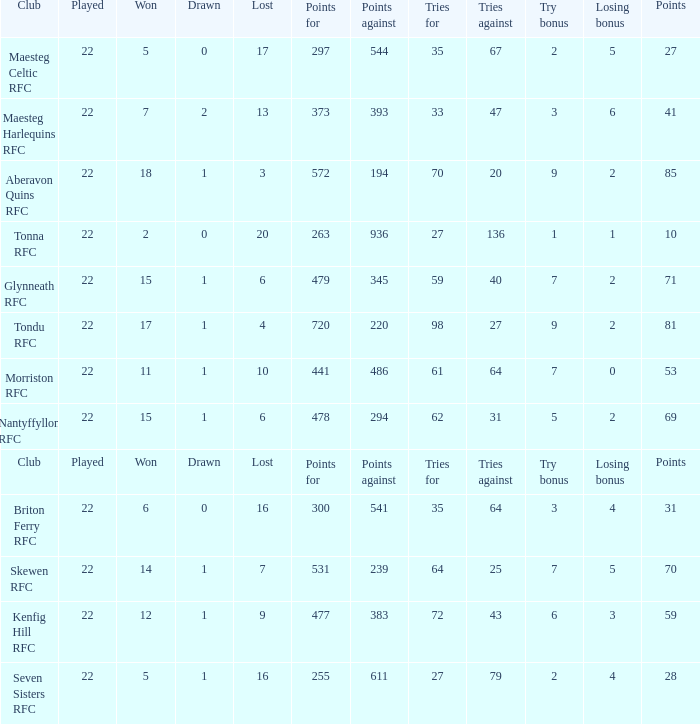How many tries against got the club with 62 tries for? 31.0. 